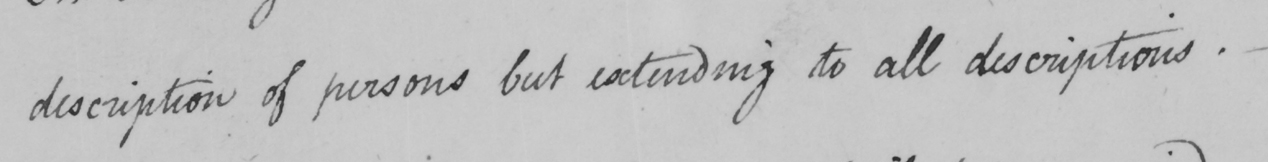Please transcribe the handwritten text in this image. description of persons but extending to all descriptions .  _ 